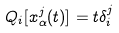<formula> <loc_0><loc_0><loc_500><loc_500>Q _ { i } [ x _ { \alpha } ^ { j } ( t ) ] = t \delta _ { i } ^ { j }</formula> 